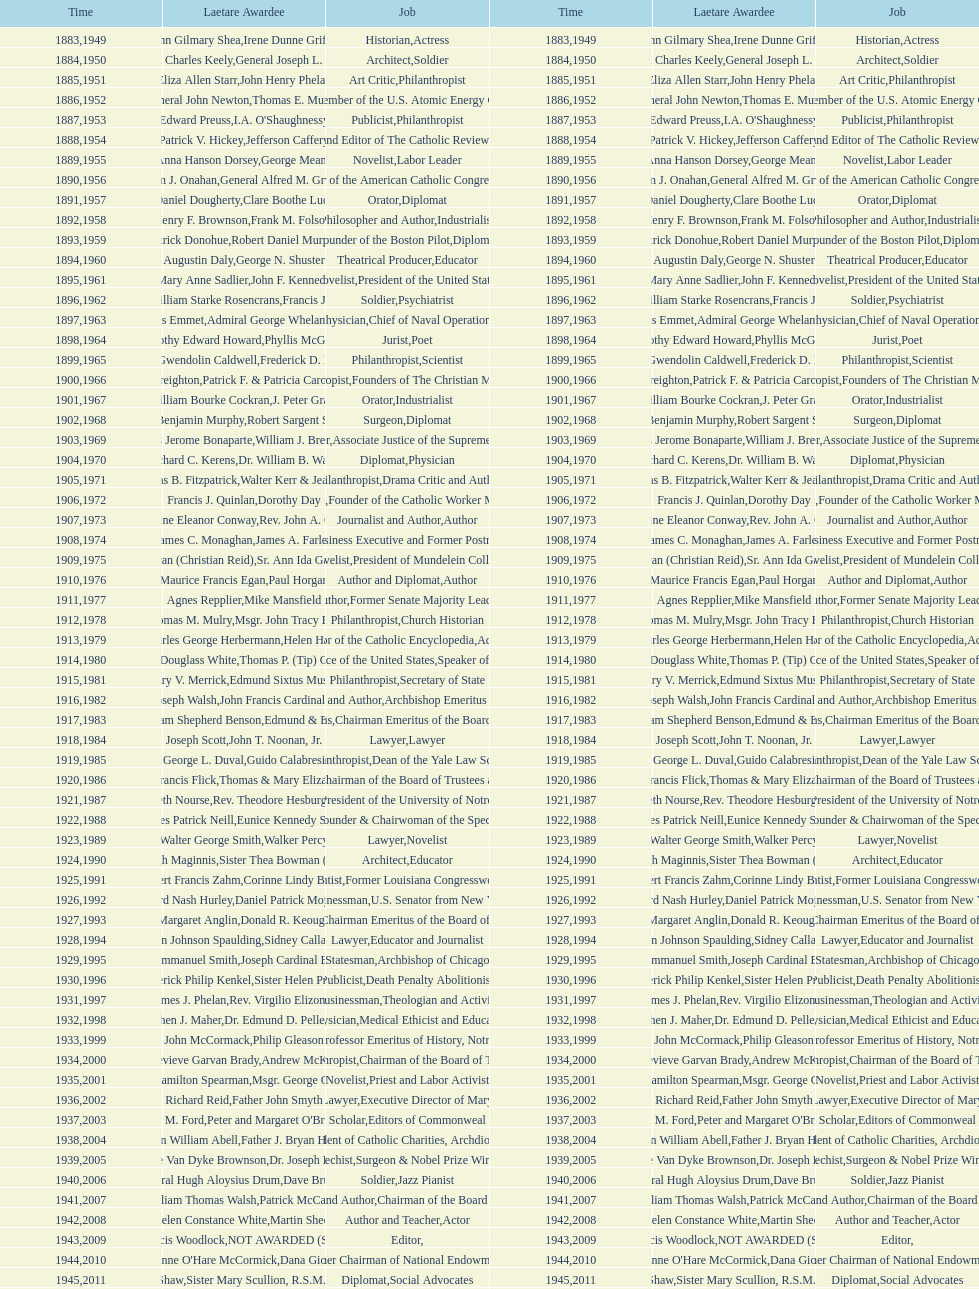Would you mind parsing the complete table? {'header': ['Time', 'Laetare Awardee', 'Job', 'Time', 'Laetare Awardee', 'Job'], 'rows': [['1883', 'John Gilmary Shea', 'Historian', '1949', 'Irene Dunne Griffin', 'Actress'], ['1884', 'Patrick Charles Keely', 'Architect', '1950', 'General Joseph L. Collins', 'Soldier'], ['1885', 'Eliza Allen Starr', 'Art Critic', '1951', 'John Henry Phelan', 'Philanthropist'], ['1886', 'General John Newton', 'Engineer', '1952', 'Thomas E. Murray', 'Member of the U.S. Atomic Energy Commission'], ['1887', 'Edward Preuss', 'Publicist', '1953', "I.A. O'Shaughnessy", 'Philanthropist'], ['1888', 'Patrick V. Hickey', 'Founder and Editor of The Catholic Review', '1954', 'Jefferson Caffery', 'Diplomat'], ['1889', 'Anna Hanson Dorsey', 'Novelist', '1955', 'George Meany', 'Labor Leader'], ['1890', 'William J. Onahan', 'Organizer of the American Catholic Congress', '1956', 'General Alfred M. Gruenther', 'Soldier'], ['1891', 'Daniel Dougherty', 'Orator', '1957', 'Clare Boothe Luce', 'Diplomat'], ['1892', 'Henry F. Brownson', 'Philosopher and Author', '1958', 'Frank M. Folsom', 'Industrialist'], ['1893', 'Patrick Donohue', 'Founder of the Boston Pilot', '1959', 'Robert Daniel Murphy', 'Diplomat'], ['1894', 'Augustin Daly', 'Theatrical Producer', '1960', 'George N. Shuster', 'Educator'], ['1895', 'Mary Anne Sadlier', 'Novelist', '1961', 'John F. Kennedy', 'President of the United States'], ['1896', 'General William Starke Rosencrans', 'Soldier', '1962', 'Francis J. Braceland', 'Psychiatrist'], ['1897', 'Thomas Addis Emmet', 'Physician', '1963', 'Admiral George Whelan Anderson, Jr.', 'Chief of Naval Operations'], ['1898', 'Timothy Edward Howard', 'Jurist', '1964', 'Phyllis McGinley', 'Poet'], ['1899', 'Mary Gwendolin Caldwell', 'Philanthropist', '1965', 'Frederick D. Rossini', 'Scientist'], ['1900', 'John A. Creighton', 'Philanthropist', '1966', 'Patrick F. & Patricia Caron Crowley', 'Founders of The Christian Movement'], ['1901', 'William Bourke Cockran', 'Orator', '1967', 'J. Peter Grace', 'Industrialist'], ['1902', 'John Benjamin Murphy', 'Surgeon', '1968', 'Robert Sargent Shriver', 'Diplomat'], ['1903', 'Charles Jerome Bonaparte', 'Lawyer', '1969', 'William J. Brennan Jr.', 'Associate Justice of the Supreme Court'], ['1904', 'Richard C. Kerens', 'Diplomat', '1970', 'Dr. William B. Walsh', 'Physician'], ['1905', 'Thomas B. Fitzpatrick', 'Philanthropist', '1971', 'Walter Kerr & Jean Kerr', 'Drama Critic and Author'], ['1906', 'Francis J. Quinlan', 'Physician', '1972', 'Dorothy Day', 'Founder of the Catholic Worker Movement'], ['1907', 'Katherine Eleanor Conway', 'Journalist and Author', '1973', "Rev. John A. O'Brien", 'Author'], ['1908', 'James C. Monaghan', 'Economist', '1974', 'James A. Farley', 'Business Executive and Former Postmaster General'], ['1909', 'Frances Tieran (Christian Reid)', 'Novelist', '1975', 'Sr. Ann Ida Gannon, BMV', 'President of Mundelein College'], ['1910', 'Maurice Francis Egan', 'Author and Diplomat', '1976', 'Paul Horgan', 'Author'], ['1911', 'Agnes Repplier', 'Author', '1977', 'Mike Mansfield', 'Former Senate Majority Leader'], ['1912', 'Thomas M. Mulry', 'Philanthropist', '1978', 'Msgr. John Tracy Ellis', 'Church Historian'], ['1913', 'Charles George Herbermann', 'Editor of the Catholic Encyclopedia', '1979', 'Helen Hayes', 'Actress'], ['1914', 'Edward Douglass White', 'Chief Justice of the United States', '1980', "Thomas P. (Tip) O'Neill Jr.", 'Speaker of the House'], ['1915', 'Mary V. Merrick', 'Philanthropist', '1981', 'Edmund Sixtus Muskie', 'Secretary of State'], ['1916', 'James Joseph Walsh', 'Physician and Author', '1982', 'John Francis Cardinal Dearden', 'Archbishop Emeritus of Detroit'], ['1917', 'Admiral William Shepherd Benson', 'Chief of Naval Operations', '1983', 'Edmund & Evelyn Stephan', 'Chairman Emeritus of the Board of Trustees and his wife'], ['1918', 'Joseph Scott', 'Lawyer', '1984', 'John T. Noonan, Jr.', 'Lawyer'], ['1919', 'George L. Duval', 'Philanthropist', '1985', 'Guido Calabresi', 'Dean of the Yale Law School'], ['1920', 'Lawrence Francis Flick', 'Physician', '1986', 'Thomas & Mary Elizabeth Carney', 'Chairman of the Board of Trustees and his wife'], ['1921', 'Elizabeth Nourse', 'Artist', '1987', 'Rev. Theodore Hesburgh, CSC', 'President of the University of Notre Dame'], ['1922', 'Charles Patrick Neill', 'Economist', '1988', 'Eunice Kennedy Shriver', 'Founder & Chairwoman of the Special Olympics'], ['1923', 'Walter George Smith', 'Lawyer', '1989', 'Walker Percy', 'Novelist'], ['1924', 'Charles Donagh Maginnis', 'Architect', '1990', 'Sister Thea Bowman (posthumously)', 'Educator'], ['1925', 'Albert Francis Zahm', 'Scientist', '1991', 'Corinne Lindy Boggs', 'Former Louisiana Congresswoman'], ['1926', 'Edward Nash Hurley', 'Businessman', '1992', 'Daniel Patrick Moynihan', 'U.S. Senator from New York'], ['1927', 'Margaret Anglin', 'Actress', '1993', 'Donald R. Keough', 'Chairman Emeritus of the Board of Trustees'], ['1928', 'John Johnson Spaulding', 'Lawyer', '1994', 'Sidney Callahan', 'Educator and Journalist'], ['1929', 'Alfred Emmanuel Smith', 'Statesman', '1995', 'Joseph Cardinal Bernardin', 'Archbishop of Chicago'], ['1930', 'Frederick Philip Kenkel', 'Publicist', '1996', 'Sister Helen Prejean', 'Death Penalty Abolitionist'], ['1931', 'James J. Phelan', 'Businessman', '1997', 'Rev. Virgilio Elizondo', 'Theologian and Activist'], ['1932', 'Stephen J. Maher', 'Physician', '1998', 'Dr. Edmund D. Pellegrino', 'Medical Ethicist and Educator'], ['1933', 'John McCormack', 'Artist', '1999', 'Philip Gleason', 'Professor Emeritus of History, Notre Dame'], ['1934', 'Genevieve Garvan Brady', 'Philanthropist', '2000', 'Andrew McKenna', 'Chairman of the Board of Trustees'], ['1935', 'Francis Hamilton Spearman', 'Novelist', '2001', 'Msgr. George G. Higgins', 'Priest and Labor Activist'], ['1936', 'Richard Reid', 'Journalist and Lawyer', '2002', 'Father John Smyth', 'Executive Director of Maryville Academy'], ['1937', 'Jeremiah D. M. Ford', 'Scholar', '2003', "Peter and Margaret O'Brien Steinfels", 'Editors of Commonweal'], ['1938', 'Irvin William Abell', 'Surgeon', '2004', 'Father J. Bryan Hehir', 'President of Catholic Charities, Archdiocese of Boston'], ['1939', 'Josephine Van Dyke Brownson', 'Catechist', '2005', 'Dr. Joseph E. Murray', 'Surgeon & Nobel Prize Winner'], ['1940', 'General Hugh Aloysius Drum', 'Soldier', '2006', 'Dave Brubeck', 'Jazz Pianist'], ['1941', 'William Thomas Walsh', 'Journalist and Author', '2007', 'Patrick McCartan', 'Chairman of the Board of Trustees'], ['1942', 'Helen Constance White', 'Author and Teacher', '2008', 'Martin Sheen', 'Actor'], ['1943', 'Thomas Francis Woodlock', 'Editor', '2009', 'NOT AWARDED (SEE BELOW)', ''], ['1944', "Anne O'Hare McCormick", 'Journalist', '2010', 'Dana Gioia', 'Former Chairman of National Endowment for the Arts'], ['1945', 'Gardiner Howland Shaw', 'Diplomat', '2011', 'Sister Mary Scullion, R.S.M., & Joan McConnon', 'Social Advocates'], ['1946', 'Carlton J. H. Hayes', 'Historian and Diplomat', '2012', 'Ken Hackett', 'Former President of Catholic Relief Services'], ['1947', 'William G. Bruce', 'Publisher and Civic Leader', '2013', 'Sister Susanne Gallagher, S.P.\\nSister Mary Therese Harrington, S.H.\\nRev. James H. McCarthy', 'Founders of S.P.R.E.D. (Special Religious Education Development Network)'], ['1948', 'Frank C. Walker', 'Postmaster General and Civic Leader', '2014', 'Kenneth R. Miller', 'Professor of Biology at Brown University']]} Who has won this medal and the nobel prize as well? Dr. Joseph E. Murray. 